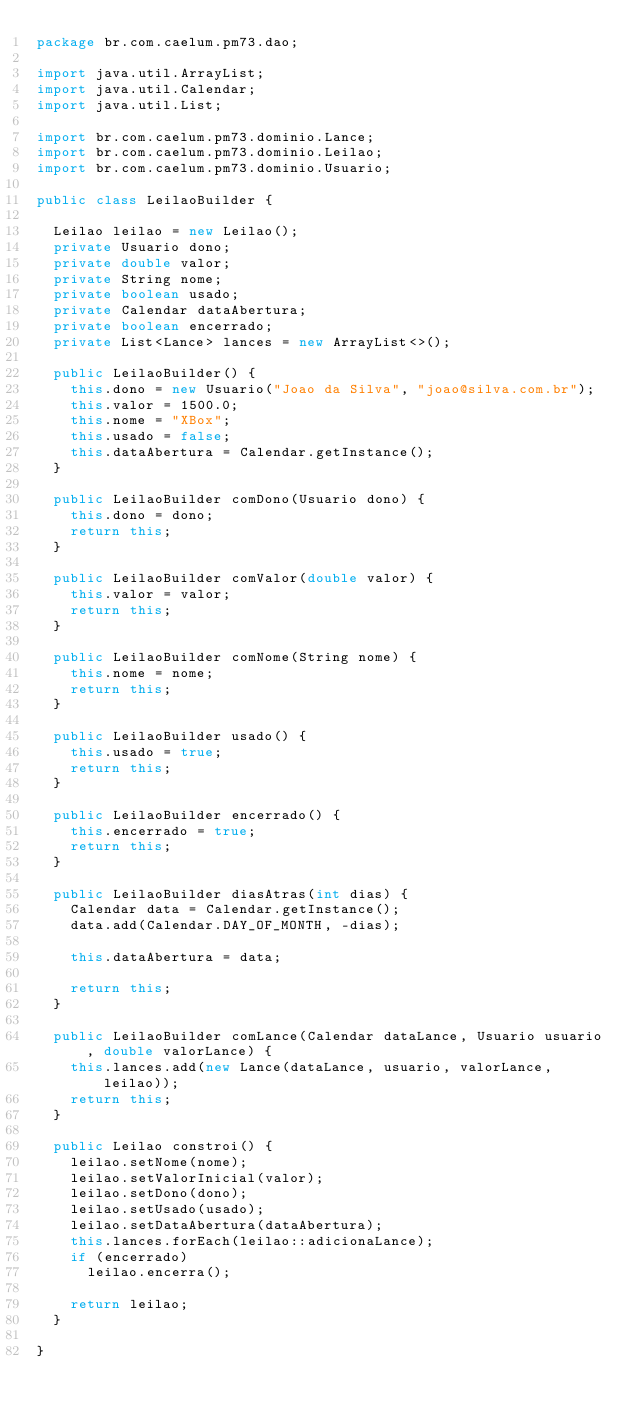Convert code to text. <code><loc_0><loc_0><loc_500><loc_500><_Java_>package br.com.caelum.pm73.dao;

import java.util.ArrayList;
import java.util.Calendar;
import java.util.List;

import br.com.caelum.pm73.dominio.Lance;
import br.com.caelum.pm73.dominio.Leilao;
import br.com.caelum.pm73.dominio.Usuario;

public class LeilaoBuilder {

	Leilao leilao = new Leilao();
	private Usuario dono;
	private double valor;
	private String nome;
	private boolean usado;
	private Calendar dataAbertura;
	private boolean encerrado;
	private List<Lance> lances = new ArrayList<>();

	public LeilaoBuilder() {
		this.dono = new Usuario("Joao da Silva", "joao@silva.com.br");
		this.valor = 1500.0;
		this.nome = "XBox";
		this.usado = false;
		this.dataAbertura = Calendar.getInstance();
	}

	public LeilaoBuilder comDono(Usuario dono) {
		this.dono = dono;
		return this;
	}

	public LeilaoBuilder comValor(double valor) {
		this.valor = valor;
		return this;
	}

	public LeilaoBuilder comNome(String nome) {
		this.nome = nome;
		return this;
	}

	public LeilaoBuilder usado() {
		this.usado = true;
		return this;
	}

	public LeilaoBuilder encerrado() {
		this.encerrado = true;
		return this;
	}

	public LeilaoBuilder diasAtras(int dias) {
		Calendar data = Calendar.getInstance();
		data.add(Calendar.DAY_OF_MONTH, -dias);

		this.dataAbertura = data;

		return this;
	}
	
	public LeilaoBuilder comLance(Calendar dataLance, Usuario usuario, double valorLance) {
		this.lances.add(new Lance(dataLance, usuario, valorLance, leilao));
		return this;
	}

	public Leilao constroi() {
		leilao.setNome(nome);
		leilao.setValorInicial(valor);
		leilao.setDono(dono);
		leilao.setUsado(usado);
		leilao.setDataAbertura(dataAbertura);
		this.lances.forEach(leilao::adicionaLance);
		if (encerrado)
			leilao.encerra();
		
		return leilao;
	}

}</code> 